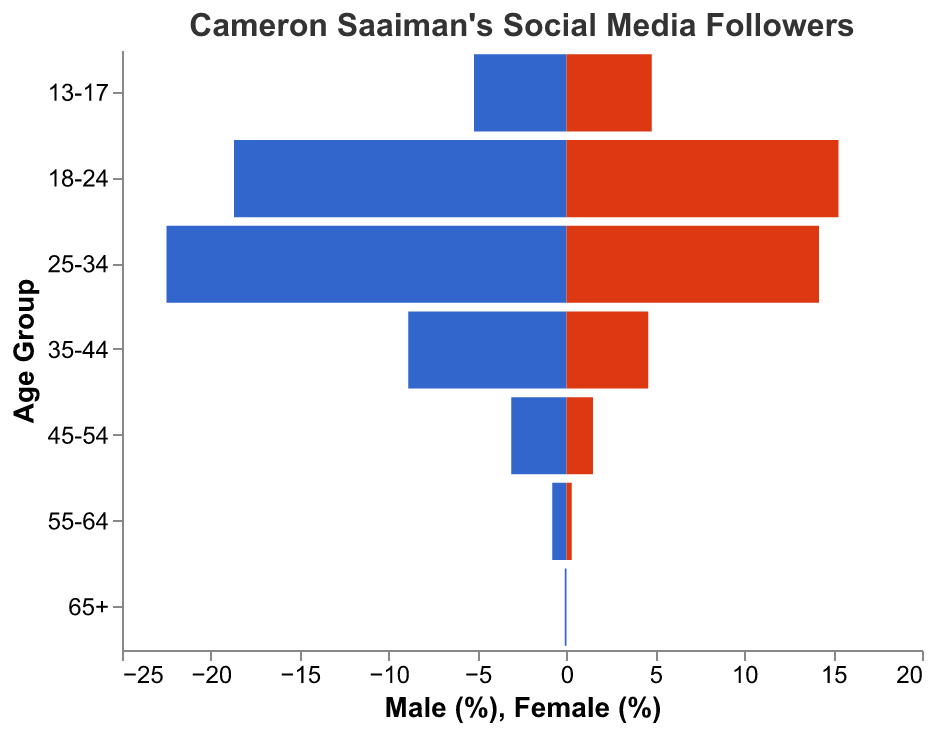What is the age group with the highest percentage of male followers? The male percentages for each age group are: 13-17 (5.2%), 18-24 (18.7%), 25-34 (22.5%), 35-44 (8.9%), 45-54 (3.1%), 55-64 (0.8%), and 65+ (0.1%). The highest is 22.5% in the 25-34 age group.
Answer: 25-34 What is the age group with the lowest percentage of female followers? The female percentages for each age group are: 13-17 (4.8%), 18-24 (15.3%), 25-34 (14.2%), 35-44 (4.6%), 45-54 (1.5%), 55-64 (0.3%), and 65+ (0.0%). The lowest is 0.0% in the 65+ age group.
Answer: 65+ What is the total percentage of followers in the 35-44 age group? Add the male percentage (8.9%) and female percentage (4.6%) for the 35-44 age group: 8.9% + 4.6% = 13.5%.
Answer: 13.5% How does the percentage of male followers in the 18-24 age group compare to the percentage of female followers in the same group? The male percentage in the 18-24 age group is 18.7%, and the female percentage is 15.3%. 18.7% is greater than 15.3%, showing a higher percentage of male followers.
Answer: 18.7% > 15.3% Which age group has the closest percentage of male to female followers? Subtract the female percentage from the male percentage for each age group and find the group with the smallest difference. For 13-17: 5.2% - 4.8% = 0.4%, 18-24: 18.7% - 15.3% = 3.4%, 25-34: 22.5% - 14.2% = 8.3%, 35-44: 8.9% - 4.6% = 4.3%, 45-54: 3.1% - 1.5% = 1.6%, 55-64: 0.8% - 0.3% = 0.5%, 65+: 0.1% - 0.0% = 0.1%. The smallest difference is 0.1% in the 65+ age group.
Answer: 65+ What is the average percentage of female followers across all age groups? Add the female percentages for all age groups and divide by the number of groups: (4.8 + 15.3 + 14.2 + 4.6 + 1.5 + 0.3 + 0.0)/7 = 40.7/7 ≈ 5.81%.
Answer: 5.81% How much higher is the percentage of male followers than female followers in the 25-34 age group? Subtract the female percentage from the male percentage in the 25-34 age group: 22.5% - 14.2% = 8.3%.
Answer: 8.3% Which age group has the least total followers? Compute the combined percentage of male and female followers for each age group, and find the smallest value. 13-17: 5.2% + 4.8% = 10%, 18-24: 18.7% + 15.3% = 34%, 25-34: 22.5% + 14.2% = 36.7%, 35-44: 8.9% + 4.6% = 13.5%, 45-54: 3.1% + 1.5% = 4.6%, 55-64: 0.8% + 0.3% = 1.1%, 65+: 0.1% + 0.0% = 0.1%. The smallest is 0.1% in the 65+ age group.
Answer: 65+ What percentage of Saaiman's followers are between the ages of 18-34 (both male and female)? Sum the percentages of male and female followers for the 18-24 and 25-34 age groups: (18.7% + 15.3%) + (22.5% + 14.2%) = 34% + 36.7% = 70.7%.
Answer: 70.7% 